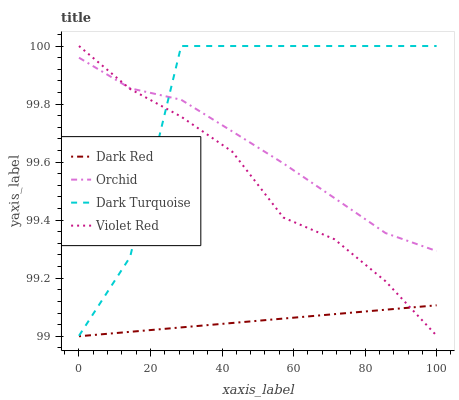Does Dark Red have the minimum area under the curve?
Answer yes or no. Yes. Does Dark Turquoise have the maximum area under the curve?
Answer yes or no. Yes. Does Violet Red have the minimum area under the curve?
Answer yes or no. No. Does Violet Red have the maximum area under the curve?
Answer yes or no. No. Is Dark Red the smoothest?
Answer yes or no. Yes. Is Dark Turquoise the roughest?
Answer yes or no. Yes. Is Violet Red the smoothest?
Answer yes or no. No. Is Violet Red the roughest?
Answer yes or no. No. Does Violet Red have the lowest value?
Answer yes or no. No. Does Orchid have the highest value?
Answer yes or no. No. Is Dark Red less than Dark Turquoise?
Answer yes or no. Yes. Is Dark Turquoise greater than Dark Red?
Answer yes or no. Yes. Does Dark Red intersect Dark Turquoise?
Answer yes or no. No. 